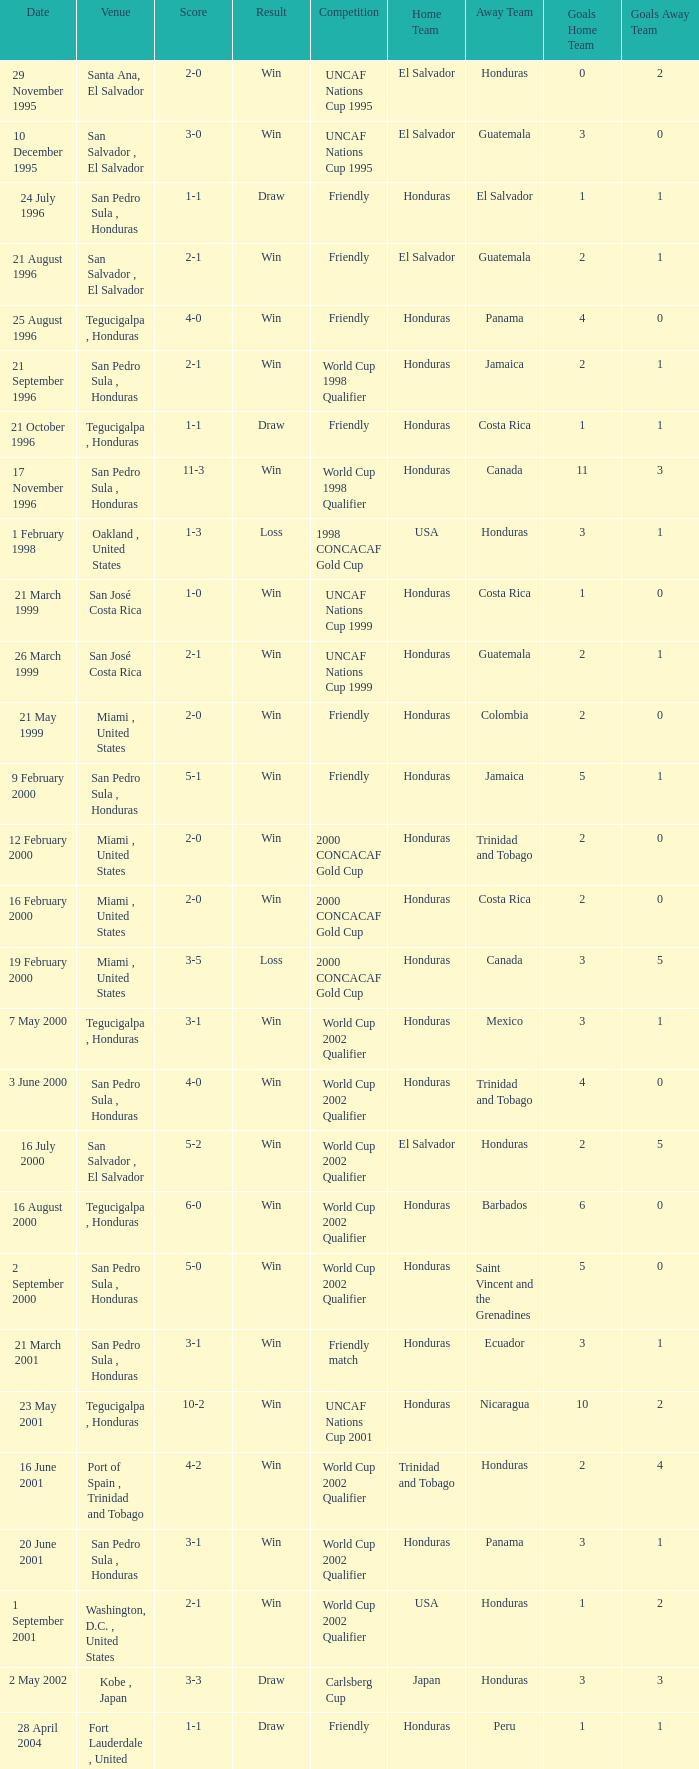Name the date of the uncaf nations cup 2009 26 January 2009. 